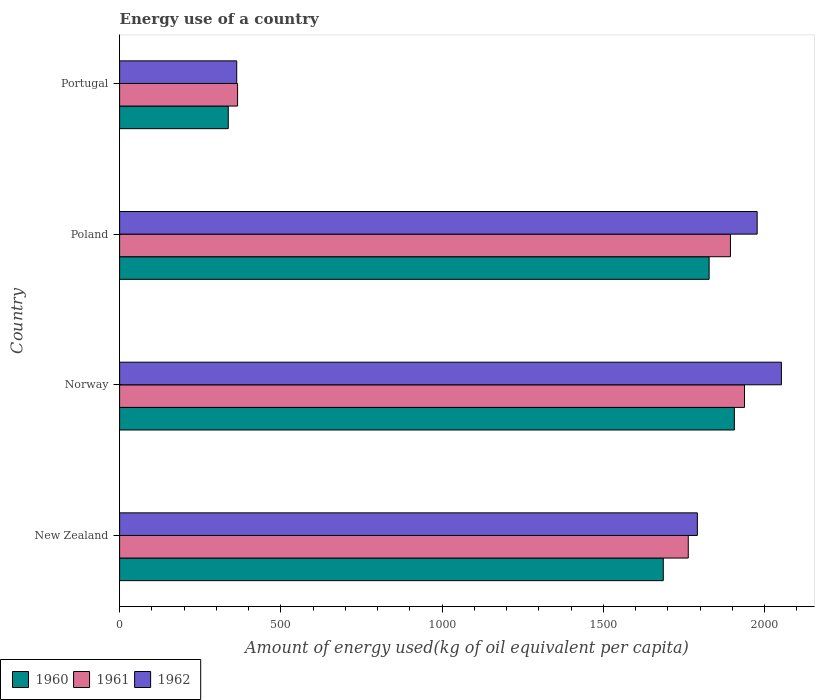Are the number of bars on each tick of the Y-axis equal?
Provide a succinct answer. Yes. What is the label of the 1st group of bars from the top?
Your answer should be very brief. Portugal. What is the amount of energy used in in 1961 in Norway?
Ensure brevity in your answer.  1937.64. Across all countries, what is the maximum amount of energy used in in 1962?
Give a very brief answer. 2052.05. Across all countries, what is the minimum amount of energy used in in 1960?
Your response must be concise. 336.91. What is the total amount of energy used in in 1960 in the graph?
Keep it short and to the point. 5756.81. What is the difference between the amount of energy used in in 1962 in Poland and that in Portugal?
Offer a very short reply. 1613.7. What is the difference between the amount of energy used in in 1960 in Poland and the amount of energy used in in 1961 in Norway?
Your answer should be compact. -109.71. What is the average amount of energy used in in 1962 per country?
Ensure brevity in your answer.  1545.88. What is the difference between the amount of energy used in in 1960 and amount of energy used in in 1962 in New Zealand?
Your answer should be very brief. -105.67. In how many countries, is the amount of energy used in in 1960 greater than 200 kg?
Ensure brevity in your answer.  4. What is the ratio of the amount of energy used in in 1960 in New Zealand to that in Poland?
Your answer should be very brief. 0.92. Is the difference between the amount of energy used in in 1960 in Norway and Poland greater than the difference between the amount of energy used in in 1962 in Norway and Poland?
Your answer should be very brief. Yes. What is the difference between the highest and the second highest amount of energy used in in 1961?
Offer a very short reply. 43.59. What is the difference between the highest and the lowest amount of energy used in in 1961?
Offer a terse response. 1571.8. In how many countries, is the amount of energy used in in 1960 greater than the average amount of energy used in in 1960 taken over all countries?
Make the answer very short. 3. Is the sum of the amount of energy used in in 1961 in Norway and Portugal greater than the maximum amount of energy used in in 1962 across all countries?
Offer a very short reply. Yes. What does the 1st bar from the top in Poland represents?
Keep it short and to the point. 1962. What does the 3rd bar from the bottom in Norway represents?
Keep it short and to the point. 1962. How many bars are there?
Provide a short and direct response. 12. Are all the bars in the graph horizontal?
Keep it short and to the point. Yes. How many countries are there in the graph?
Make the answer very short. 4. What is the difference between two consecutive major ticks on the X-axis?
Keep it short and to the point. 500. Are the values on the major ticks of X-axis written in scientific E-notation?
Give a very brief answer. No. Does the graph contain grids?
Offer a terse response. No. Where does the legend appear in the graph?
Provide a short and direct response. Bottom left. What is the title of the graph?
Keep it short and to the point. Energy use of a country. What is the label or title of the X-axis?
Provide a succinct answer. Amount of energy used(kg of oil equivalent per capita). What is the label or title of the Y-axis?
Offer a terse response. Country. What is the Amount of energy used(kg of oil equivalent per capita) of 1960 in New Zealand?
Make the answer very short. 1685.79. What is the Amount of energy used(kg of oil equivalent per capita) in 1961 in New Zealand?
Your answer should be compact. 1763.26. What is the Amount of energy used(kg of oil equivalent per capita) of 1962 in New Zealand?
Give a very brief answer. 1791.46. What is the Amount of energy used(kg of oil equivalent per capita) in 1960 in Norway?
Offer a terse response. 1906.17. What is the Amount of energy used(kg of oil equivalent per capita) in 1961 in Norway?
Provide a short and direct response. 1937.64. What is the Amount of energy used(kg of oil equivalent per capita) of 1962 in Norway?
Make the answer very short. 2052.05. What is the Amount of energy used(kg of oil equivalent per capita) of 1960 in Poland?
Your response must be concise. 1827.94. What is the Amount of energy used(kg of oil equivalent per capita) of 1961 in Poland?
Ensure brevity in your answer.  1894.06. What is the Amount of energy used(kg of oil equivalent per capita) in 1962 in Poland?
Make the answer very short. 1976.86. What is the Amount of energy used(kg of oil equivalent per capita) in 1960 in Portugal?
Your answer should be compact. 336.91. What is the Amount of energy used(kg of oil equivalent per capita) in 1961 in Portugal?
Your answer should be compact. 365.84. What is the Amount of energy used(kg of oil equivalent per capita) in 1962 in Portugal?
Your response must be concise. 363.16. Across all countries, what is the maximum Amount of energy used(kg of oil equivalent per capita) in 1960?
Your answer should be very brief. 1906.17. Across all countries, what is the maximum Amount of energy used(kg of oil equivalent per capita) in 1961?
Keep it short and to the point. 1937.64. Across all countries, what is the maximum Amount of energy used(kg of oil equivalent per capita) in 1962?
Provide a succinct answer. 2052.05. Across all countries, what is the minimum Amount of energy used(kg of oil equivalent per capita) of 1960?
Offer a terse response. 336.91. Across all countries, what is the minimum Amount of energy used(kg of oil equivalent per capita) of 1961?
Your answer should be very brief. 365.84. Across all countries, what is the minimum Amount of energy used(kg of oil equivalent per capita) of 1962?
Ensure brevity in your answer.  363.16. What is the total Amount of energy used(kg of oil equivalent per capita) in 1960 in the graph?
Provide a short and direct response. 5756.81. What is the total Amount of energy used(kg of oil equivalent per capita) of 1961 in the graph?
Your answer should be very brief. 5960.8. What is the total Amount of energy used(kg of oil equivalent per capita) of 1962 in the graph?
Your answer should be very brief. 6183.54. What is the difference between the Amount of energy used(kg of oil equivalent per capita) of 1960 in New Zealand and that in Norway?
Keep it short and to the point. -220.39. What is the difference between the Amount of energy used(kg of oil equivalent per capita) of 1961 in New Zealand and that in Norway?
Keep it short and to the point. -174.38. What is the difference between the Amount of energy used(kg of oil equivalent per capita) of 1962 in New Zealand and that in Norway?
Ensure brevity in your answer.  -260.59. What is the difference between the Amount of energy used(kg of oil equivalent per capita) of 1960 in New Zealand and that in Poland?
Ensure brevity in your answer.  -142.15. What is the difference between the Amount of energy used(kg of oil equivalent per capita) in 1961 in New Zealand and that in Poland?
Keep it short and to the point. -130.8. What is the difference between the Amount of energy used(kg of oil equivalent per capita) of 1962 in New Zealand and that in Poland?
Provide a short and direct response. -185.4. What is the difference between the Amount of energy used(kg of oil equivalent per capita) in 1960 in New Zealand and that in Portugal?
Your response must be concise. 1348.87. What is the difference between the Amount of energy used(kg of oil equivalent per capita) of 1961 in New Zealand and that in Portugal?
Offer a terse response. 1397.42. What is the difference between the Amount of energy used(kg of oil equivalent per capita) of 1962 in New Zealand and that in Portugal?
Provide a succinct answer. 1428.3. What is the difference between the Amount of energy used(kg of oil equivalent per capita) of 1960 in Norway and that in Poland?
Provide a short and direct response. 78.24. What is the difference between the Amount of energy used(kg of oil equivalent per capita) in 1961 in Norway and that in Poland?
Ensure brevity in your answer.  43.59. What is the difference between the Amount of energy used(kg of oil equivalent per capita) in 1962 in Norway and that in Poland?
Your response must be concise. 75.19. What is the difference between the Amount of energy used(kg of oil equivalent per capita) in 1960 in Norway and that in Portugal?
Provide a short and direct response. 1569.26. What is the difference between the Amount of energy used(kg of oil equivalent per capita) in 1961 in Norway and that in Portugal?
Offer a very short reply. 1571.8. What is the difference between the Amount of energy used(kg of oil equivalent per capita) in 1962 in Norway and that in Portugal?
Provide a short and direct response. 1688.89. What is the difference between the Amount of energy used(kg of oil equivalent per capita) of 1960 in Poland and that in Portugal?
Make the answer very short. 1491.02. What is the difference between the Amount of energy used(kg of oil equivalent per capita) of 1961 in Poland and that in Portugal?
Offer a terse response. 1528.22. What is the difference between the Amount of energy used(kg of oil equivalent per capita) in 1962 in Poland and that in Portugal?
Your answer should be very brief. 1613.7. What is the difference between the Amount of energy used(kg of oil equivalent per capita) of 1960 in New Zealand and the Amount of energy used(kg of oil equivalent per capita) of 1961 in Norway?
Make the answer very short. -251.86. What is the difference between the Amount of energy used(kg of oil equivalent per capita) in 1960 in New Zealand and the Amount of energy used(kg of oil equivalent per capita) in 1962 in Norway?
Offer a very short reply. -366.27. What is the difference between the Amount of energy used(kg of oil equivalent per capita) in 1961 in New Zealand and the Amount of energy used(kg of oil equivalent per capita) in 1962 in Norway?
Ensure brevity in your answer.  -288.79. What is the difference between the Amount of energy used(kg of oil equivalent per capita) in 1960 in New Zealand and the Amount of energy used(kg of oil equivalent per capita) in 1961 in Poland?
Provide a short and direct response. -208.27. What is the difference between the Amount of energy used(kg of oil equivalent per capita) of 1960 in New Zealand and the Amount of energy used(kg of oil equivalent per capita) of 1962 in Poland?
Give a very brief answer. -291.07. What is the difference between the Amount of energy used(kg of oil equivalent per capita) of 1961 in New Zealand and the Amount of energy used(kg of oil equivalent per capita) of 1962 in Poland?
Your answer should be very brief. -213.6. What is the difference between the Amount of energy used(kg of oil equivalent per capita) in 1960 in New Zealand and the Amount of energy used(kg of oil equivalent per capita) in 1961 in Portugal?
Offer a terse response. 1319.95. What is the difference between the Amount of energy used(kg of oil equivalent per capita) of 1960 in New Zealand and the Amount of energy used(kg of oil equivalent per capita) of 1962 in Portugal?
Ensure brevity in your answer.  1322.62. What is the difference between the Amount of energy used(kg of oil equivalent per capita) of 1961 in New Zealand and the Amount of energy used(kg of oil equivalent per capita) of 1962 in Portugal?
Your response must be concise. 1400.1. What is the difference between the Amount of energy used(kg of oil equivalent per capita) of 1960 in Norway and the Amount of energy used(kg of oil equivalent per capita) of 1961 in Poland?
Your answer should be very brief. 12.12. What is the difference between the Amount of energy used(kg of oil equivalent per capita) in 1960 in Norway and the Amount of energy used(kg of oil equivalent per capita) in 1962 in Poland?
Provide a succinct answer. -70.68. What is the difference between the Amount of energy used(kg of oil equivalent per capita) in 1961 in Norway and the Amount of energy used(kg of oil equivalent per capita) in 1962 in Poland?
Keep it short and to the point. -39.22. What is the difference between the Amount of energy used(kg of oil equivalent per capita) of 1960 in Norway and the Amount of energy used(kg of oil equivalent per capita) of 1961 in Portugal?
Ensure brevity in your answer.  1540.33. What is the difference between the Amount of energy used(kg of oil equivalent per capita) of 1960 in Norway and the Amount of energy used(kg of oil equivalent per capita) of 1962 in Portugal?
Make the answer very short. 1543.01. What is the difference between the Amount of energy used(kg of oil equivalent per capita) in 1961 in Norway and the Amount of energy used(kg of oil equivalent per capita) in 1962 in Portugal?
Offer a very short reply. 1574.48. What is the difference between the Amount of energy used(kg of oil equivalent per capita) of 1960 in Poland and the Amount of energy used(kg of oil equivalent per capita) of 1961 in Portugal?
Provide a short and direct response. 1462.1. What is the difference between the Amount of energy used(kg of oil equivalent per capita) of 1960 in Poland and the Amount of energy used(kg of oil equivalent per capita) of 1962 in Portugal?
Offer a very short reply. 1464.77. What is the difference between the Amount of energy used(kg of oil equivalent per capita) of 1961 in Poland and the Amount of energy used(kg of oil equivalent per capita) of 1962 in Portugal?
Offer a terse response. 1530.89. What is the average Amount of energy used(kg of oil equivalent per capita) in 1960 per country?
Provide a succinct answer. 1439.2. What is the average Amount of energy used(kg of oil equivalent per capita) of 1961 per country?
Keep it short and to the point. 1490.2. What is the average Amount of energy used(kg of oil equivalent per capita) in 1962 per country?
Keep it short and to the point. 1545.88. What is the difference between the Amount of energy used(kg of oil equivalent per capita) in 1960 and Amount of energy used(kg of oil equivalent per capita) in 1961 in New Zealand?
Ensure brevity in your answer.  -77.47. What is the difference between the Amount of energy used(kg of oil equivalent per capita) of 1960 and Amount of energy used(kg of oil equivalent per capita) of 1962 in New Zealand?
Provide a short and direct response. -105.67. What is the difference between the Amount of energy used(kg of oil equivalent per capita) in 1961 and Amount of energy used(kg of oil equivalent per capita) in 1962 in New Zealand?
Make the answer very short. -28.2. What is the difference between the Amount of energy used(kg of oil equivalent per capita) of 1960 and Amount of energy used(kg of oil equivalent per capita) of 1961 in Norway?
Keep it short and to the point. -31.47. What is the difference between the Amount of energy used(kg of oil equivalent per capita) of 1960 and Amount of energy used(kg of oil equivalent per capita) of 1962 in Norway?
Provide a short and direct response. -145.88. What is the difference between the Amount of energy used(kg of oil equivalent per capita) in 1961 and Amount of energy used(kg of oil equivalent per capita) in 1962 in Norway?
Make the answer very short. -114.41. What is the difference between the Amount of energy used(kg of oil equivalent per capita) in 1960 and Amount of energy used(kg of oil equivalent per capita) in 1961 in Poland?
Your answer should be compact. -66.12. What is the difference between the Amount of energy used(kg of oil equivalent per capita) of 1960 and Amount of energy used(kg of oil equivalent per capita) of 1962 in Poland?
Your answer should be very brief. -148.92. What is the difference between the Amount of energy used(kg of oil equivalent per capita) in 1961 and Amount of energy used(kg of oil equivalent per capita) in 1962 in Poland?
Offer a very short reply. -82.8. What is the difference between the Amount of energy used(kg of oil equivalent per capita) in 1960 and Amount of energy used(kg of oil equivalent per capita) in 1961 in Portugal?
Your answer should be compact. -28.93. What is the difference between the Amount of energy used(kg of oil equivalent per capita) in 1960 and Amount of energy used(kg of oil equivalent per capita) in 1962 in Portugal?
Your response must be concise. -26.25. What is the difference between the Amount of energy used(kg of oil equivalent per capita) of 1961 and Amount of energy used(kg of oil equivalent per capita) of 1962 in Portugal?
Your response must be concise. 2.68. What is the ratio of the Amount of energy used(kg of oil equivalent per capita) of 1960 in New Zealand to that in Norway?
Offer a terse response. 0.88. What is the ratio of the Amount of energy used(kg of oil equivalent per capita) in 1961 in New Zealand to that in Norway?
Your response must be concise. 0.91. What is the ratio of the Amount of energy used(kg of oil equivalent per capita) in 1962 in New Zealand to that in Norway?
Keep it short and to the point. 0.87. What is the ratio of the Amount of energy used(kg of oil equivalent per capita) of 1960 in New Zealand to that in Poland?
Your answer should be compact. 0.92. What is the ratio of the Amount of energy used(kg of oil equivalent per capita) in 1961 in New Zealand to that in Poland?
Your answer should be compact. 0.93. What is the ratio of the Amount of energy used(kg of oil equivalent per capita) in 1962 in New Zealand to that in Poland?
Provide a succinct answer. 0.91. What is the ratio of the Amount of energy used(kg of oil equivalent per capita) in 1960 in New Zealand to that in Portugal?
Provide a succinct answer. 5. What is the ratio of the Amount of energy used(kg of oil equivalent per capita) of 1961 in New Zealand to that in Portugal?
Keep it short and to the point. 4.82. What is the ratio of the Amount of energy used(kg of oil equivalent per capita) of 1962 in New Zealand to that in Portugal?
Give a very brief answer. 4.93. What is the ratio of the Amount of energy used(kg of oil equivalent per capita) in 1960 in Norway to that in Poland?
Provide a succinct answer. 1.04. What is the ratio of the Amount of energy used(kg of oil equivalent per capita) in 1962 in Norway to that in Poland?
Ensure brevity in your answer.  1.04. What is the ratio of the Amount of energy used(kg of oil equivalent per capita) in 1960 in Norway to that in Portugal?
Offer a very short reply. 5.66. What is the ratio of the Amount of energy used(kg of oil equivalent per capita) in 1961 in Norway to that in Portugal?
Your answer should be compact. 5.3. What is the ratio of the Amount of energy used(kg of oil equivalent per capita) in 1962 in Norway to that in Portugal?
Your answer should be compact. 5.65. What is the ratio of the Amount of energy used(kg of oil equivalent per capita) of 1960 in Poland to that in Portugal?
Offer a very short reply. 5.43. What is the ratio of the Amount of energy used(kg of oil equivalent per capita) in 1961 in Poland to that in Portugal?
Your response must be concise. 5.18. What is the ratio of the Amount of energy used(kg of oil equivalent per capita) of 1962 in Poland to that in Portugal?
Keep it short and to the point. 5.44. What is the difference between the highest and the second highest Amount of energy used(kg of oil equivalent per capita) in 1960?
Your response must be concise. 78.24. What is the difference between the highest and the second highest Amount of energy used(kg of oil equivalent per capita) of 1961?
Provide a succinct answer. 43.59. What is the difference between the highest and the second highest Amount of energy used(kg of oil equivalent per capita) of 1962?
Keep it short and to the point. 75.19. What is the difference between the highest and the lowest Amount of energy used(kg of oil equivalent per capita) in 1960?
Offer a very short reply. 1569.26. What is the difference between the highest and the lowest Amount of energy used(kg of oil equivalent per capita) of 1961?
Give a very brief answer. 1571.8. What is the difference between the highest and the lowest Amount of energy used(kg of oil equivalent per capita) in 1962?
Your response must be concise. 1688.89. 